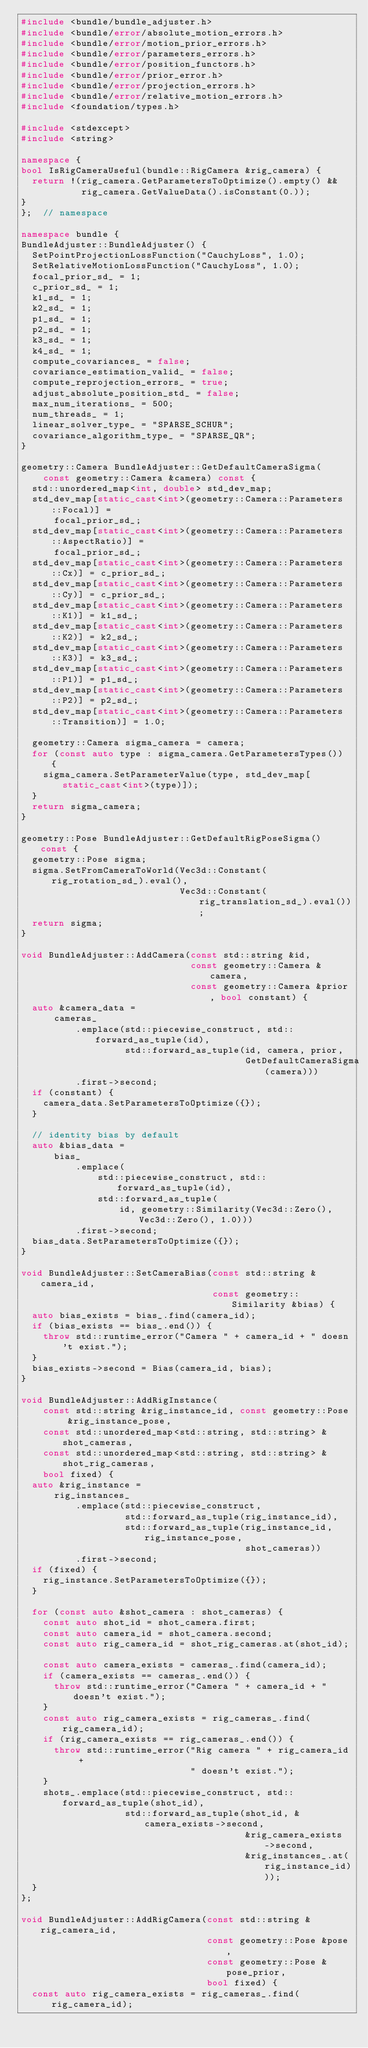Convert code to text. <code><loc_0><loc_0><loc_500><loc_500><_C++_>#include <bundle/bundle_adjuster.h>
#include <bundle/error/absolute_motion_errors.h>
#include <bundle/error/motion_prior_errors.h>
#include <bundle/error/parameters_errors.h>
#include <bundle/error/position_functors.h>
#include <bundle/error/prior_error.h>
#include <bundle/error/projection_errors.h>
#include <bundle/error/relative_motion_errors.h>
#include <foundation/types.h>

#include <stdexcept>
#include <string>

namespace {
bool IsRigCameraUseful(bundle::RigCamera &rig_camera) {
  return !(rig_camera.GetParametersToOptimize().empty() &&
           rig_camera.GetValueData().isConstant(0.));
}
};  // namespace

namespace bundle {
BundleAdjuster::BundleAdjuster() {
  SetPointProjectionLossFunction("CauchyLoss", 1.0);
  SetRelativeMotionLossFunction("CauchyLoss", 1.0);
  focal_prior_sd_ = 1;
  c_prior_sd_ = 1;
  k1_sd_ = 1;
  k2_sd_ = 1;
  p1_sd_ = 1;
  p2_sd_ = 1;
  k3_sd_ = 1;
  k4_sd_ = 1;
  compute_covariances_ = false;
  covariance_estimation_valid_ = false;
  compute_reprojection_errors_ = true;
  adjust_absolute_position_std_ = false;
  max_num_iterations_ = 500;
  num_threads_ = 1;
  linear_solver_type_ = "SPARSE_SCHUR";
  covariance_algorithm_type_ = "SPARSE_QR";
}

geometry::Camera BundleAdjuster::GetDefaultCameraSigma(
    const geometry::Camera &camera) const {
  std::unordered_map<int, double> std_dev_map;
  std_dev_map[static_cast<int>(geometry::Camera::Parameters::Focal)] =
      focal_prior_sd_;
  std_dev_map[static_cast<int>(geometry::Camera::Parameters::AspectRatio)] =
      focal_prior_sd_;
  std_dev_map[static_cast<int>(geometry::Camera::Parameters::Cx)] = c_prior_sd_;
  std_dev_map[static_cast<int>(geometry::Camera::Parameters::Cy)] = c_prior_sd_;
  std_dev_map[static_cast<int>(geometry::Camera::Parameters::K1)] = k1_sd_;
  std_dev_map[static_cast<int>(geometry::Camera::Parameters::K2)] = k2_sd_;
  std_dev_map[static_cast<int>(geometry::Camera::Parameters::K3)] = k3_sd_;
  std_dev_map[static_cast<int>(geometry::Camera::Parameters::P1)] = p1_sd_;
  std_dev_map[static_cast<int>(geometry::Camera::Parameters::P2)] = p2_sd_;
  std_dev_map[static_cast<int>(geometry::Camera::Parameters::Transition)] = 1.0;

  geometry::Camera sigma_camera = camera;
  for (const auto type : sigma_camera.GetParametersTypes()) {
    sigma_camera.SetParameterValue(type, std_dev_map[static_cast<int>(type)]);
  }
  return sigma_camera;
}

geometry::Pose BundleAdjuster::GetDefaultRigPoseSigma() const {
  geometry::Pose sigma;
  sigma.SetFromCameraToWorld(Vec3d::Constant(rig_rotation_sd_).eval(),
                             Vec3d::Constant(rig_translation_sd_).eval());
  return sigma;
}

void BundleAdjuster::AddCamera(const std::string &id,
                               const geometry::Camera &camera,
                               const geometry::Camera &prior, bool constant) {
  auto &camera_data =
      cameras_
          .emplace(std::piecewise_construct, std::forward_as_tuple(id),
                   std::forward_as_tuple(id, camera, prior,
                                         GetDefaultCameraSigma(camera)))
          .first->second;
  if (constant) {
    camera_data.SetParametersToOptimize({});
  }

  // identity bias by default
  auto &bias_data =
      bias_
          .emplace(
              std::piecewise_construct, std::forward_as_tuple(id),
              std::forward_as_tuple(
                  id, geometry::Similarity(Vec3d::Zero(), Vec3d::Zero(), 1.0)))
          .first->second;
  bias_data.SetParametersToOptimize({});
}

void BundleAdjuster::SetCameraBias(const std::string &camera_id,
                                   const geometry::Similarity &bias) {
  auto bias_exists = bias_.find(camera_id);
  if (bias_exists == bias_.end()) {
    throw std::runtime_error("Camera " + camera_id + " doesn't exist.");
  }
  bias_exists->second = Bias(camera_id, bias);
}

void BundleAdjuster::AddRigInstance(
    const std::string &rig_instance_id, const geometry::Pose &rig_instance_pose,
    const std::unordered_map<std::string, std::string> &shot_cameras,
    const std::unordered_map<std::string, std::string> &shot_rig_cameras,
    bool fixed) {
  auto &rig_instance =
      rig_instances_
          .emplace(std::piecewise_construct,
                   std::forward_as_tuple(rig_instance_id),
                   std::forward_as_tuple(rig_instance_id, rig_instance_pose,
                                         shot_cameras))
          .first->second;
  if (fixed) {
    rig_instance.SetParametersToOptimize({});
  }

  for (const auto &shot_camera : shot_cameras) {
    const auto shot_id = shot_camera.first;
    const auto camera_id = shot_camera.second;
    const auto rig_camera_id = shot_rig_cameras.at(shot_id);

    const auto camera_exists = cameras_.find(camera_id);
    if (camera_exists == cameras_.end()) {
      throw std::runtime_error("Camera " + camera_id + " doesn't exist.");
    }
    const auto rig_camera_exists = rig_cameras_.find(rig_camera_id);
    if (rig_camera_exists == rig_cameras_.end()) {
      throw std::runtime_error("Rig camera " + rig_camera_id +
                               " doesn't exist.");
    }
    shots_.emplace(std::piecewise_construct, std::forward_as_tuple(shot_id),
                   std::forward_as_tuple(shot_id, &camera_exists->second,
                                         &rig_camera_exists->second,
                                         &rig_instances_.at(rig_instance_id)));
  }
};

void BundleAdjuster::AddRigCamera(const std::string &rig_camera_id,
                                  const geometry::Pose &pose,
                                  const geometry::Pose &pose_prior,
                                  bool fixed) {
  const auto rig_camera_exists = rig_cameras_.find(rig_camera_id);</code> 